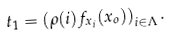Convert formula to latex. <formula><loc_0><loc_0><loc_500><loc_500>t _ { 1 } = \left ( \rho ( i ) f _ { x _ { i } } ( x _ { o } ) \right ) _ { i \in \Lambda } .</formula> 